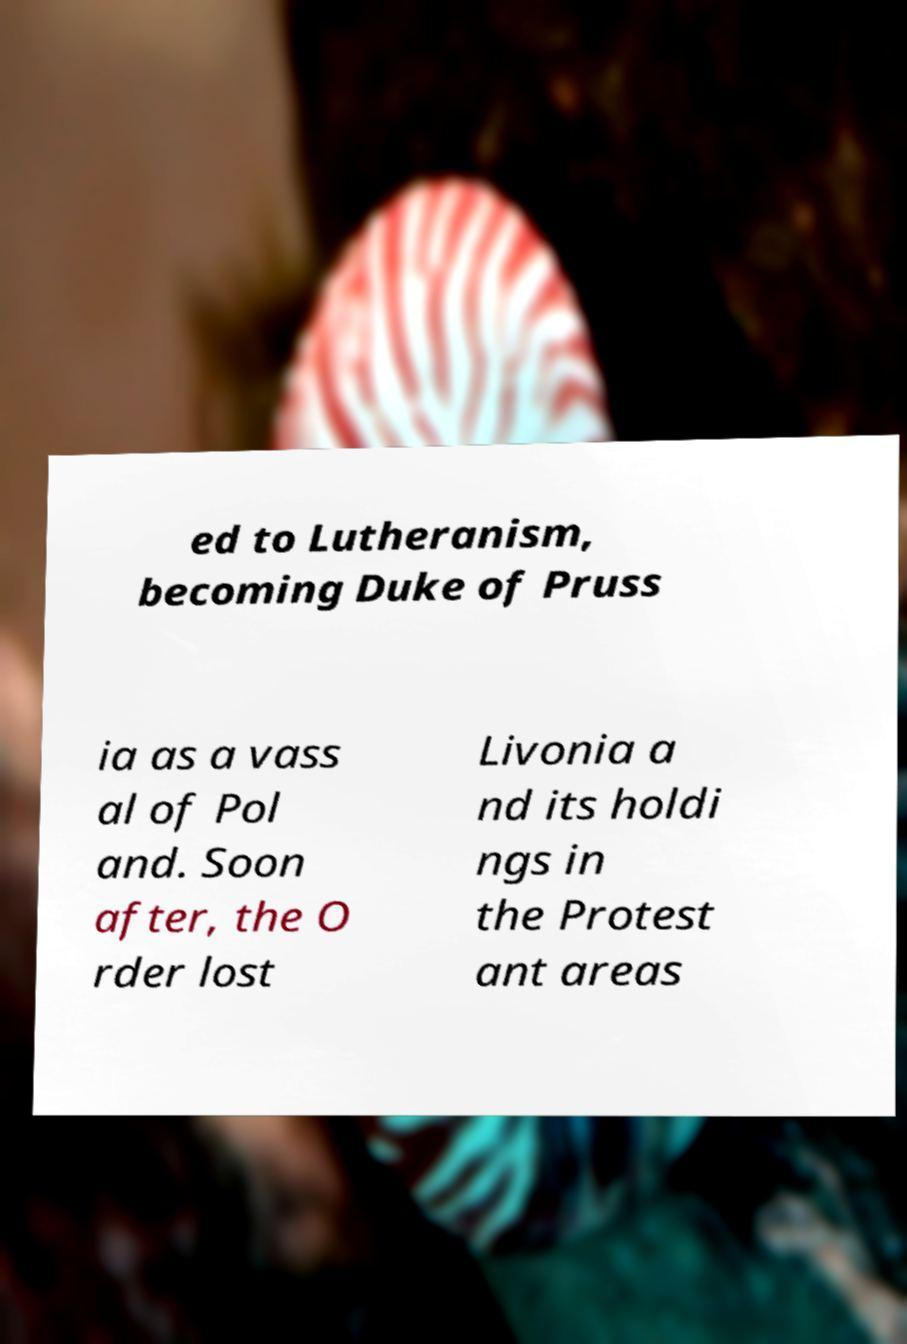Please read and relay the text visible in this image. What does it say? ed to Lutheranism, becoming Duke of Pruss ia as a vass al of Pol and. Soon after, the O rder lost Livonia a nd its holdi ngs in the Protest ant areas 